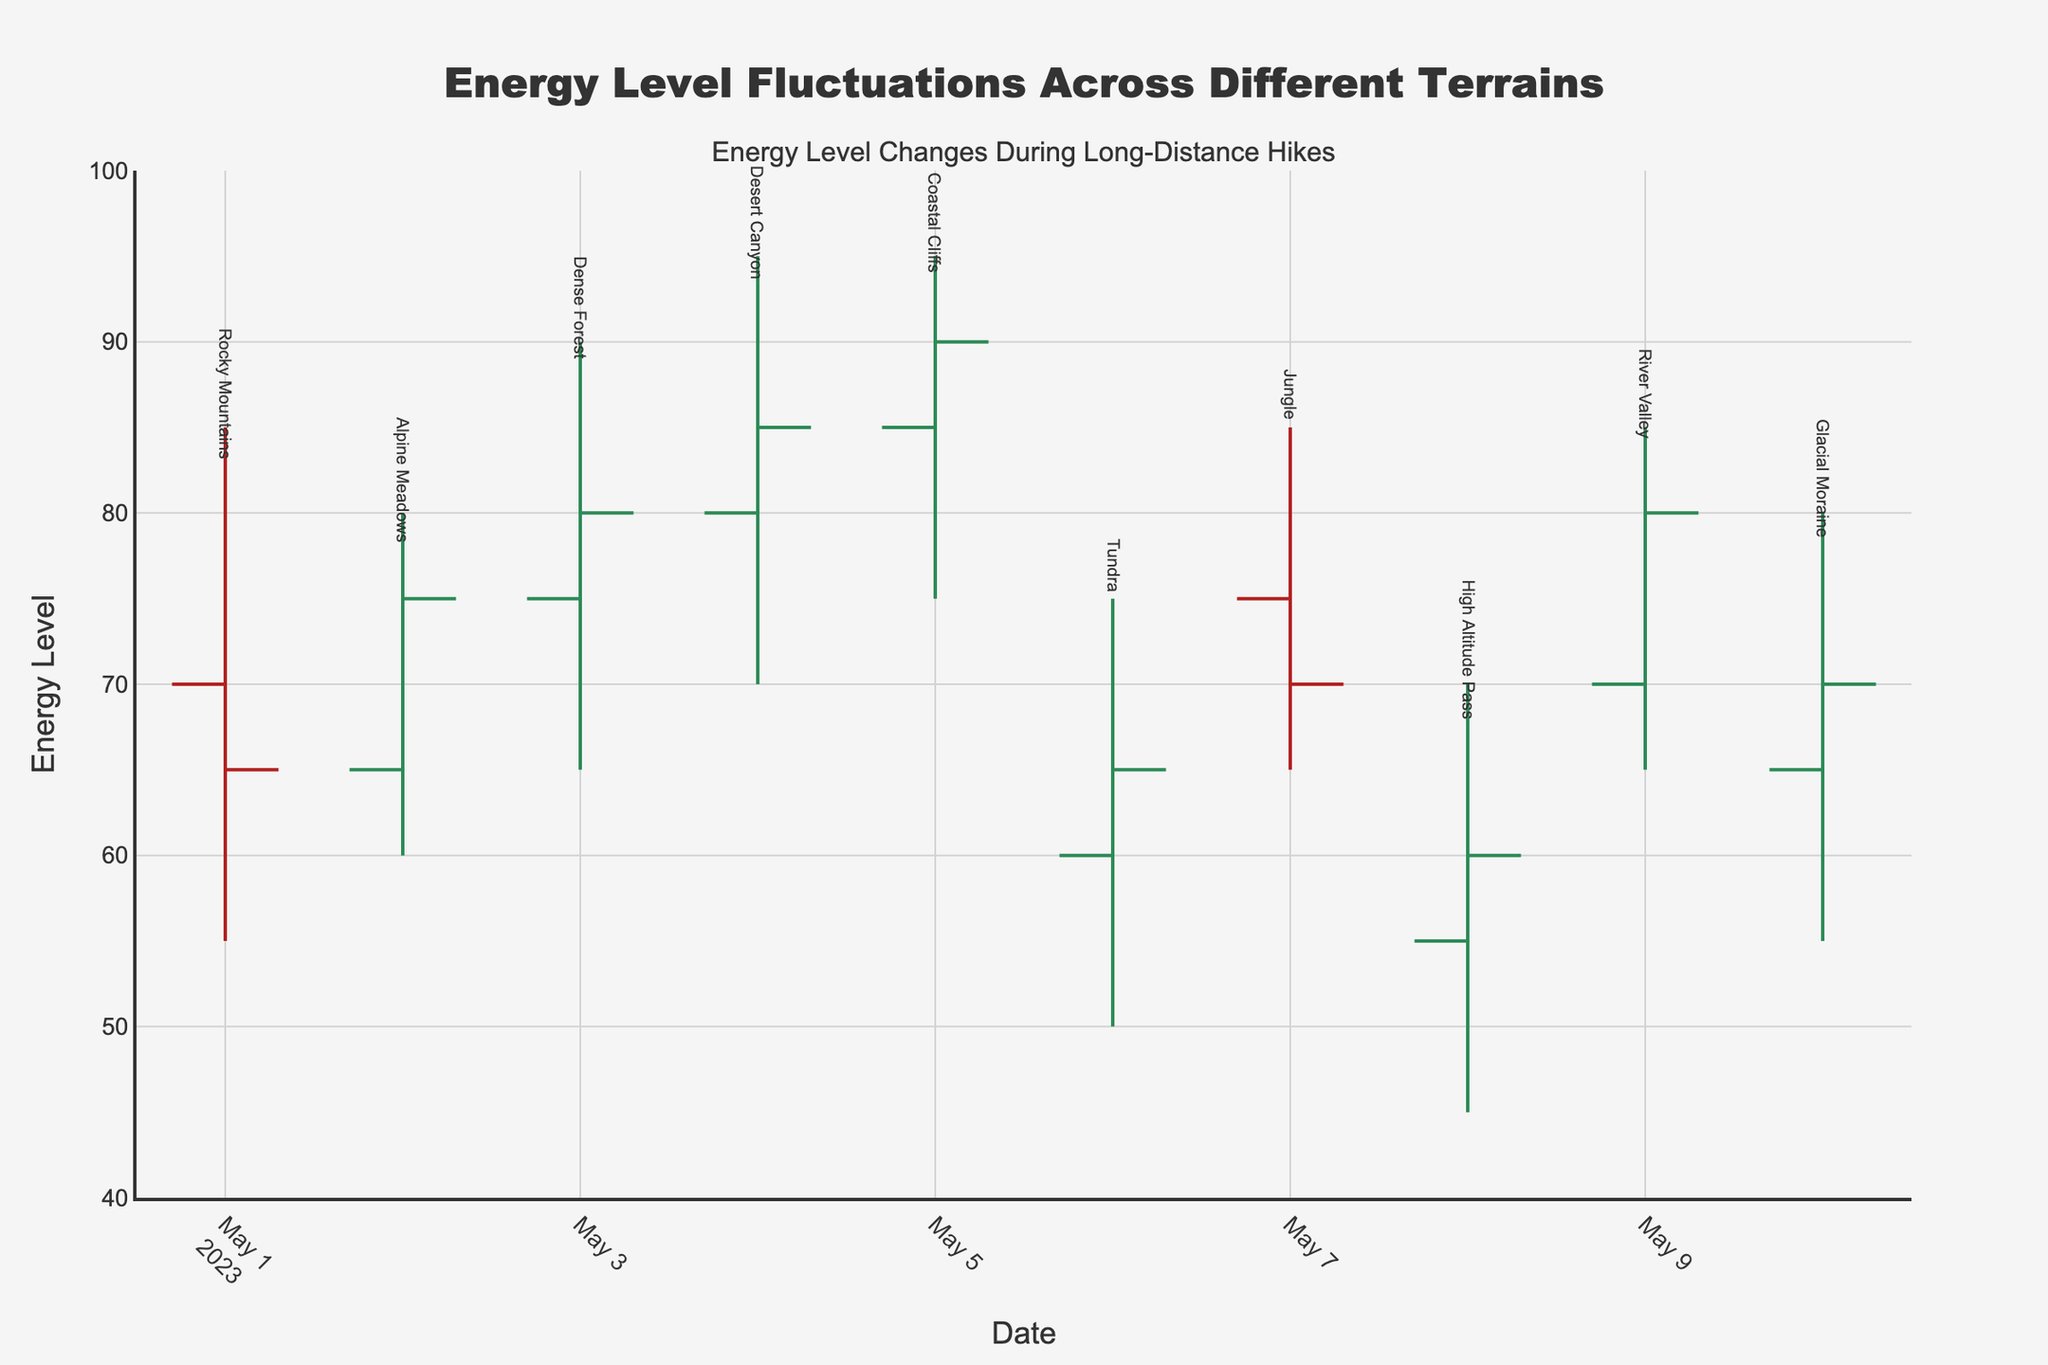What is the title of the chart? The title of the chart is displayed at the top in bold font and large size to catch attention.
Answer: Energy Level Fluctuations Across Different Terrains What do the y-axis labels represent? The y-axis labels represent the energy level measurements, ranging from 40 to 100.
Answer: Energy Level What was the highest recorded energy level in the Dense Forest terrain? Check the high value for the Dense Forest on May 3rd.
Answer: 90 Which terrain shows the lowest energy level during the observation period? Look for the lowest value across all terrains; the lowest is recorded in the High Altitude Pass.
Answer: High Altitude Pass How does the energy level variation in the Rocky Mountains compare to that in the Desert Canyon? Compare the range between the high and low values for both terrains. The Rocky Mountains range from 85 to 55, while Desert Canyon ranges from 95 to 70.
Answer: Rocky Mountains: 85-55, Desert Canyon: 95-70 What is the open energy level in the Alpine Meadows? The open energy level for May 2nd indicates the energy at the start of the day.
Answer: 65 Calculate the average closing energy level across all terrains. Sum the closing values for each terrain and divide by the number of terrains (65 + 75 + 80 + 85 + 90 + 65 + 70 + 60 + 80 + 70) / 10 = 74
Answer: 74 On which date did the Tundra terrain have its highest energy level, and what was it? The Tundra terrain's highest energy level is marked on May 6th.
Answer: May 6, 75 How does the closing energy level on May 5th in Coastal Cliffs compare to the closing energy level on May 10th in Glacial Moraine? Compare the closing values noted for May 5th and May 10th.
Answer: Coastal Cliffs: 90, Glacial Moraine: 70 Identify two terrains where the energy level did not drop below 65. Look for terrains where the low value is 65 or above; these are Dense Forest and River Valley.
Answer: Dense Forest, River Valley 